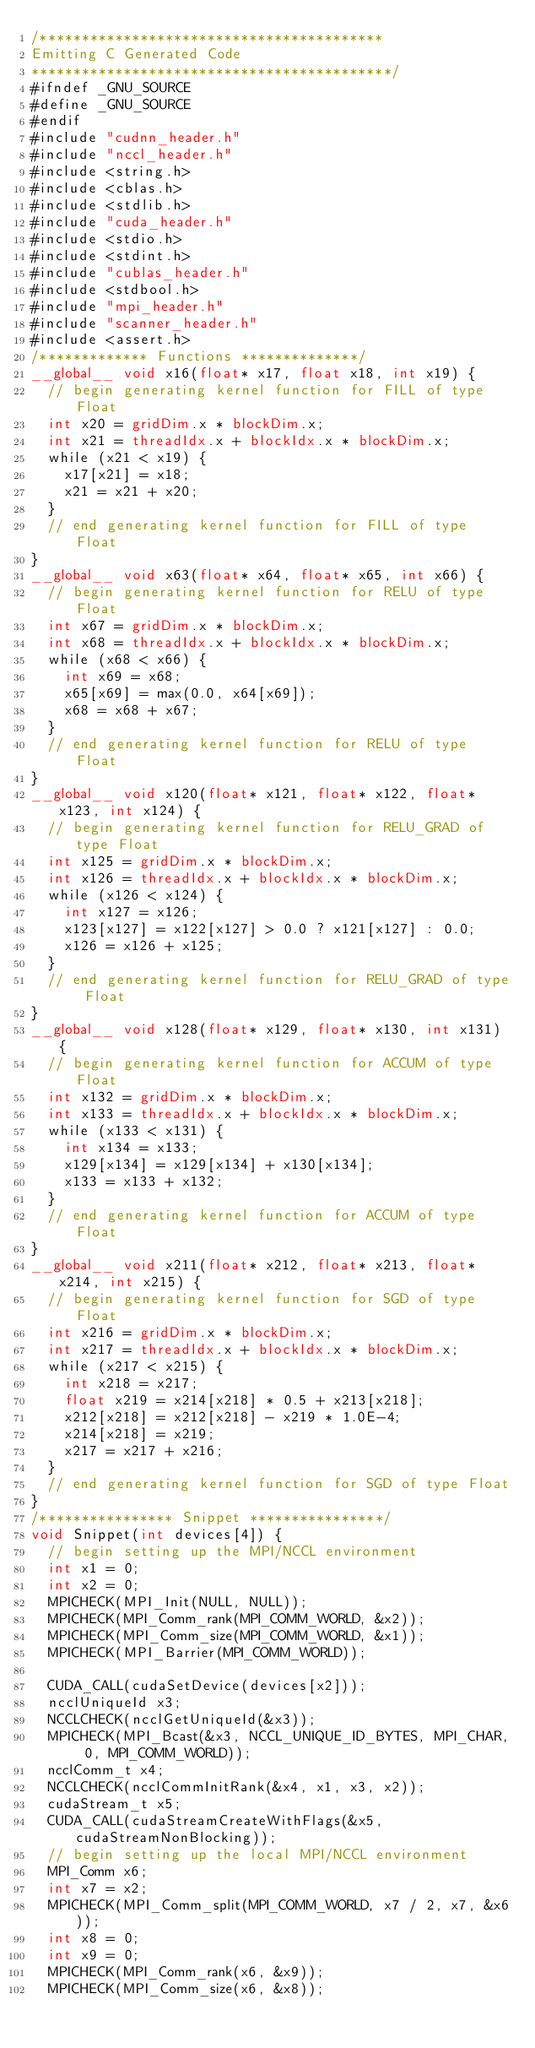<code> <loc_0><loc_0><loc_500><loc_500><_Cuda_>/*****************************************
Emitting C Generated Code
*******************************************/
#ifndef _GNU_SOURCE
#define _GNU_SOURCE
#endif
#include "cudnn_header.h"
#include "nccl_header.h"
#include <string.h>
#include <cblas.h>
#include <stdlib.h>
#include "cuda_header.h"
#include <stdio.h>
#include <stdint.h>
#include "cublas_header.h"
#include <stdbool.h>
#include "mpi_header.h"
#include "scanner_header.h"
#include <assert.h>
/************* Functions **************/
__global__ void x16(float* x17, float x18, int x19) {
  // begin generating kernel function for FILL of type Float
  int x20 = gridDim.x * blockDim.x;
  int x21 = threadIdx.x + blockIdx.x * blockDim.x;
  while (x21 < x19) {
    x17[x21] = x18;
    x21 = x21 + x20;
  }
  // end generating kernel function for FILL of type Float
}
__global__ void x63(float* x64, float* x65, int x66) {
  // begin generating kernel function for RELU of type Float
  int x67 = gridDim.x * blockDim.x;
  int x68 = threadIdx.x + blockIdx.x * blockDim.x;
  while (x68 < x66) {
    int x69 = x68;
    x65[x69] = max(0.0, x64[x69]);
    x68 = x68 + x67;
  }
  // end generating kernel function for RELU of type Float
}
__global__ void x120(float* x121, float* x122, float* x123, int x124) {
  // begin generating kernel function for RELU_GRAD of type Float
  int x125 = gridDim.x * blockDim.x;
  int x126 = threadIdx.x + blockIdx.x * blockDim.x;
  while (x126 < x124) {
    int x127 = x126;
    x123[x127] = x122[x127] > 0.0 ? x121[x127] : 0.0;
    x126 = x126 + x125;
  }
  // end generating kernel function for RELU_GRAD of type Float
}
__global__ void x128(float* x129, float* x130, int x131) {
  // begin generating kernel function for ACCUM of type Float
  int x132 = gridDim.x * blockDim.x;
  int x133 = threadIdx.x + blockIdx.x * blockDim.x;
  while (x133 < x131) {
    int x134 = x133;
    x129[x134] = x129[x134] + x130[x134];
    x133 = x133 + x132;
  }
  // end generating kernel function for ACCUM of type Float
}
__global__ void x211(float* x212, float* x213, float* x214, int x215) {
  // begin generating kernel function for SGD of type Float
  int x216 = gridDim.x * blockDim.x;
  int x217 = threadIdx.x + blockIdx.x * blockDim.x;
  while (x217 < x215) {
    int x218 = x217;
    float x219 = x214[x218] * 0.5 + x213[x218];
    x212[x218] = x212[x218] - x219 * 1.0E-4;
    x214[x218] = x219;
    x217 = x217 + x216;
  }
  // end generating kernel function for SGD of type Float
}
/**************** Snippet ****************/
void Snippet(int devices[4]) {
  // begin setting up the MPI/NCCL environment
  int x1 = 0;
  int x2 = 0;
  MPICHECK(MPI_Init(NULL, NULL));
  MPICHECK(MPI_Comm_rank(MPI_COMM_WORLD, &x2));
  MPICHECK(MPI_Comm_size(MPI_COMM_WORLD, &x1));
  MPICHECK(MPI_Barrier(MPI_COMM_WORLD));

  CUDA_CALL(cudaSetDevice(devices[x2]));
  ncclUniqueId x3;
  NCCLCHECK(ncclGetUniqueId(&x3));
  MPICHECK(MPI_Bcast(&x3, NCCL_UNIQUE_ID_BYTES, MPI_CHAR, 0, MPI_COMM_WORLD));
  ncclComm_t x4;
  NCCLCHECK(ncclCommInitRank(&x4, x1, x3, x2));
  cudaStream_t x5;
  CUDA_CALL(cudaStreamCreateWithFlags(&x5, cudaStreamNonBlocking));
  // begin setting up the local MPI/NCCL environment
  MPI_Comm x6;
  int x7 = x2;
  MPICHECK(MPI_Comm_split(MPI_COMM_WORLD, x7 / 2, x7, &x6));
  int x8 = 0;
  int x9 = 0;
  MPICHECK(MPI_Comm_rank(x6, &x9));
  MPICHECK(MPI_Comm_size(x6, &x8));</code> 